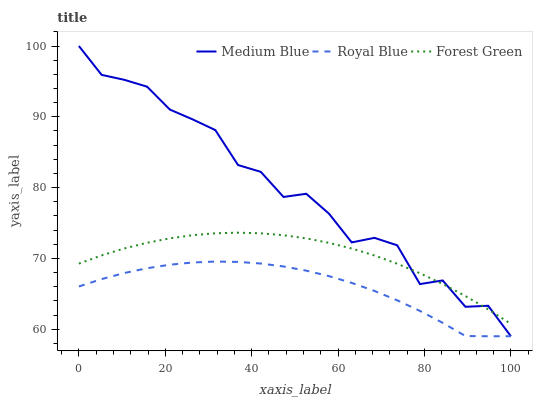Does Royal Blue have the minimum area under the curve?
Answer yes or no. Yes. Does Medium Blue have the maximum area under the curve?
Answer yes or no. Yes. Does Forest Green have the minimum area under the curve?
Answer yes or no. No. Does Forest Green have the maximum area under the curve?
Answer yes or no. No. Is Forest Green the smoothest?
Answer yes or no. Yes. Is Medium Blue the roughest?
Answer yes or no. Yes. Is Medium Blue the smoothest?
Answer yes or no. No. Is Forest Green the roughest?
Answer yes or no. No. Does Royal Blue have the lowest value?
Answer yes or no. Yes. Does Forest Green have the lowest value?
Answer yes or no. No. Does Medium Blue have the highest value?
Answer yes or no. Yes. Does Forest Green have the highest value?
Answer yes or no. No. Is Royal Blue less than Forest Green?
Answer yes or no. Yes. Is Forest Green greater than Royal Blue?
Answer yes or no. Yes. Does Medium Blue intersect Royal Blue?
Answer yes or no. Yes. Is Medium Blue less than Royal Blue?
Answer yes or no. No. Is Medium Blue greater than Royal Blue?
Answer yes or no. No. Does Royal Blue intersect Forest Green?
Answer yes or no. No. 